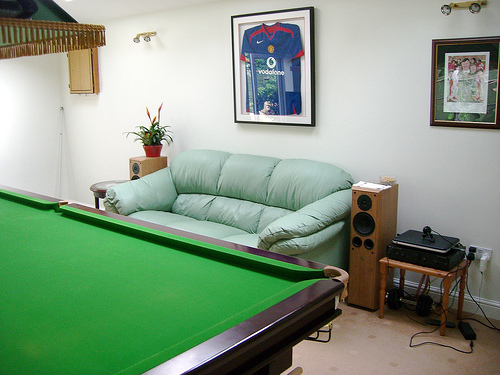<image>
Is the table behind the couch? No. The table is not behind the couch. From this viewpoint, the table appears to be positioned elsewhere in the scene. Is there a sofa on the pool table? No. The sofa is not positioned on the pool table. They may be near each other, but the sofa is not supported by or resting on top of the pool table. 